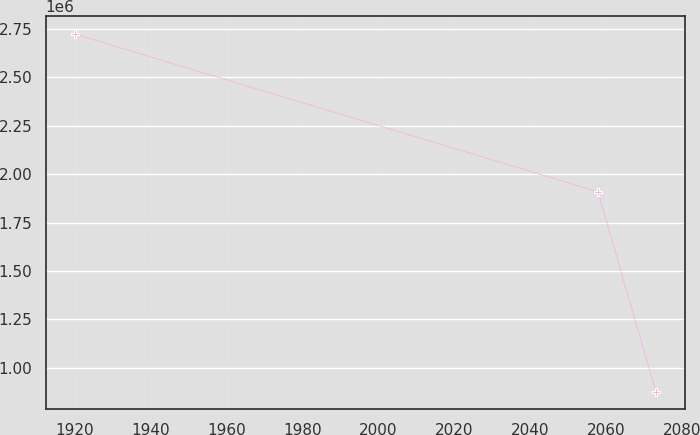Convert chart to OTSL. <chart><loc_0><loc_0><loc_500><loc_500><line_chart><ecel><fcel>Unnamed: 1<nl><fcel>1919.99<fcel>2.72431e+06<nl><fcel>2057.85<fcel>1.90945e+06<nl><fcel>2073.1<fcel>877997<nl></chart> 